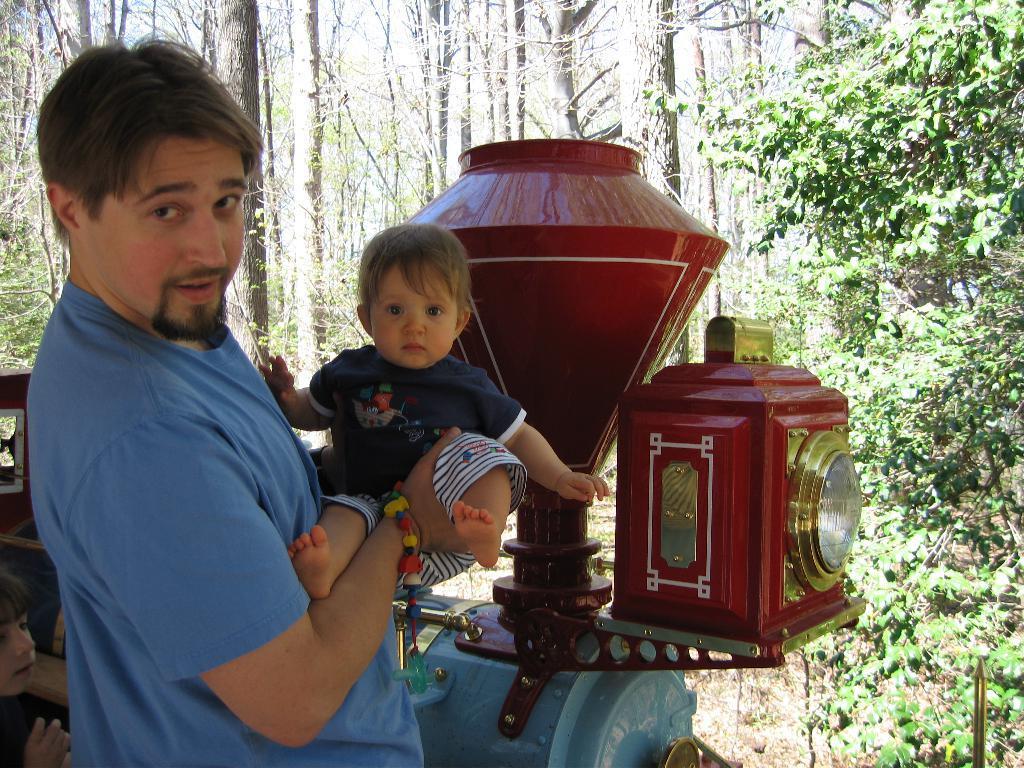Could you give a brief overview of what you see in this image? In this picture, we can see a person holding a baby, and we can see toy train, and we can see child in bottom left corner, and we can see ground, plants and the trees. 